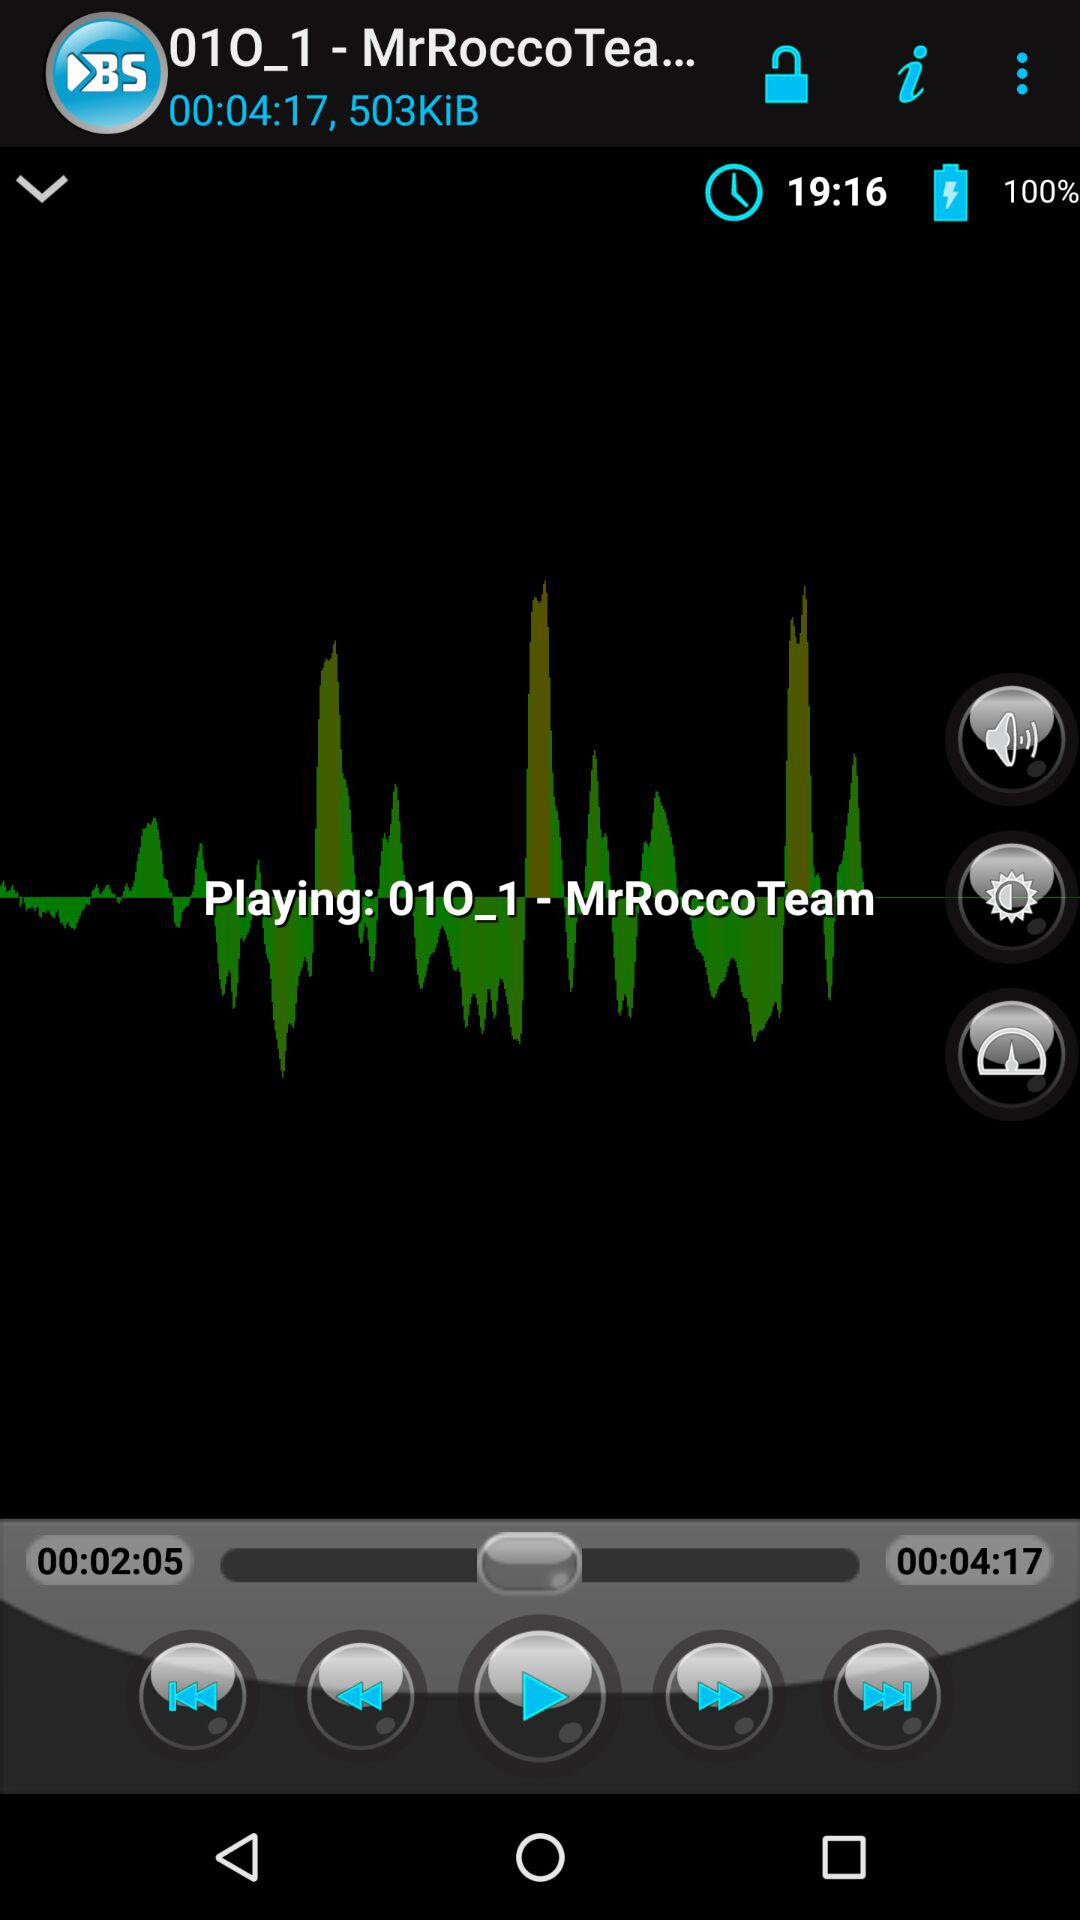How long is the video?
Answer the question using a single word or phrase. 00:04:17 